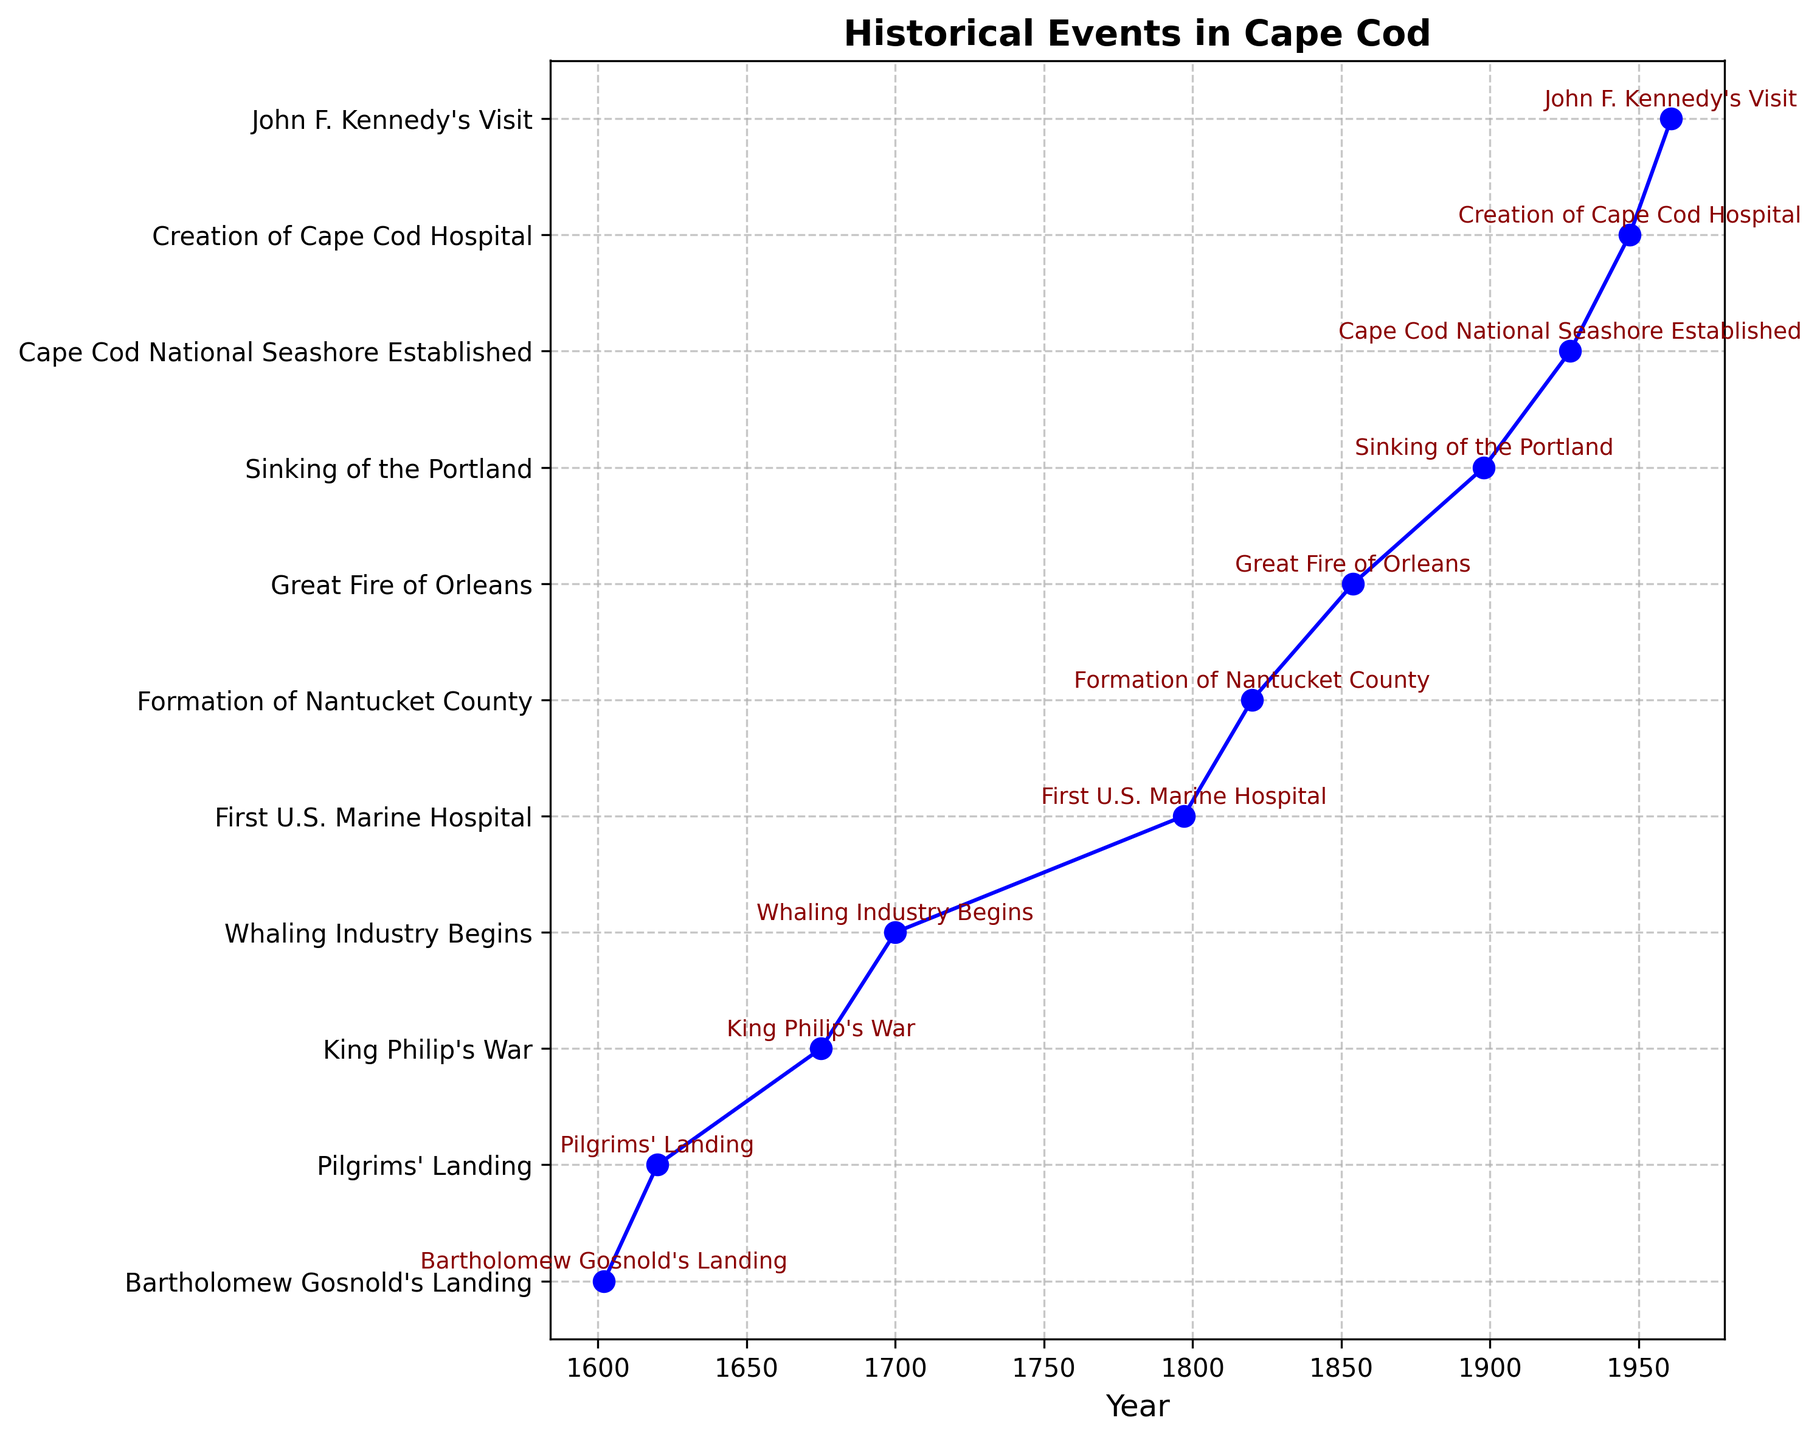What event occurred in the earliest year on the plot? The event with the earliest year is the first plotted data point on the x-axis. Referring to the plot, the first year is 1602.
Answer: Bartholomew Gosnold's Landing How many years after Bartholomew Gosnold's Landing did the Pilgrims land at Provincetown? To determine the years between the two events, subtract the year 1602 from 1620.
Answer: 18 years Which event occurred closer to the year 1854: the formation of Nantucket County or the Great Fire of Orleans? Compare the years 1820 (Formation of Nantucket County) and 1854 to see which is closer to 1854. The difference is 34 years for the Formation of Nantucket County and 0 years for the Great Fire of Orleans.
Answer: Great Fire of Orleans How is the median year in the first five events on the plot determined, and what is it? List the years of the first five events (1602, 1620, 1675, 1700, 1797) and find the middle value. The median of these sorted years is the third value.
Answer: 1675 Which events occurred in the 20th century? Identify events between the years 1901 and 2000. According to the plot, the years 1927 and 1947 fall in this range.
Answer: Cape Cod National Seashore Established, Creation of Cape Cod Hospital Which event, between King Philip's War and the sinking of the Portland, occurred first? Compare the years 1675 (King Philip's War) and 1898 (Sinking of the Portland). The event with 1675 occurred earlier.
Answer: King Philip's War What is the time span between the foundation of Cape Cod Hospital and John F. Kennedy's Visit? Subtract the year 1947 from 1961 to determine the number of years between these two events.
Answer: 14 years Which event took place 27 years after the formation of Nantucket County? Add 27 years to the year 1820, resulting in the year 1847. However, the closest event on the plot is the Great Fire of Orleans in 1854.
Answer: Great Fire of Orleans What is the total number of years from Bartholomew Gosnold's Landing to John F. Kennedy's Visit? Subtract 1602 from 1961 to find the total time span between the two events.
Answer: 359 years 